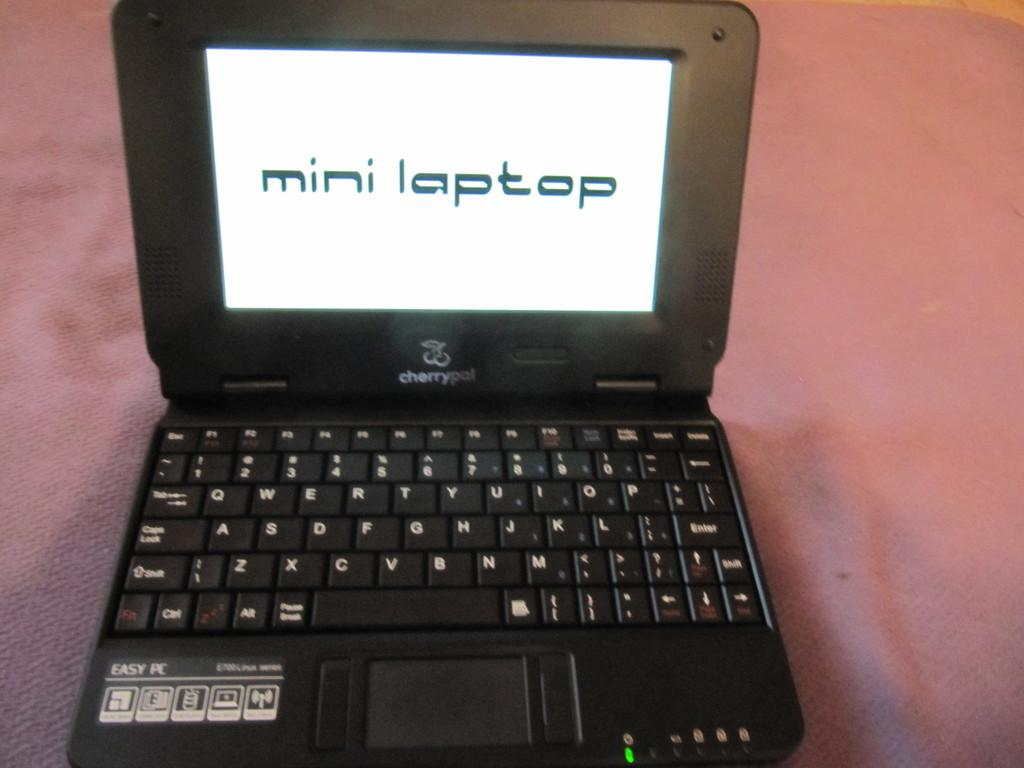Provide a one-sentence caption for the provided image. a black cherrypal laptop that has a screen on that says 'mini laptop'. 